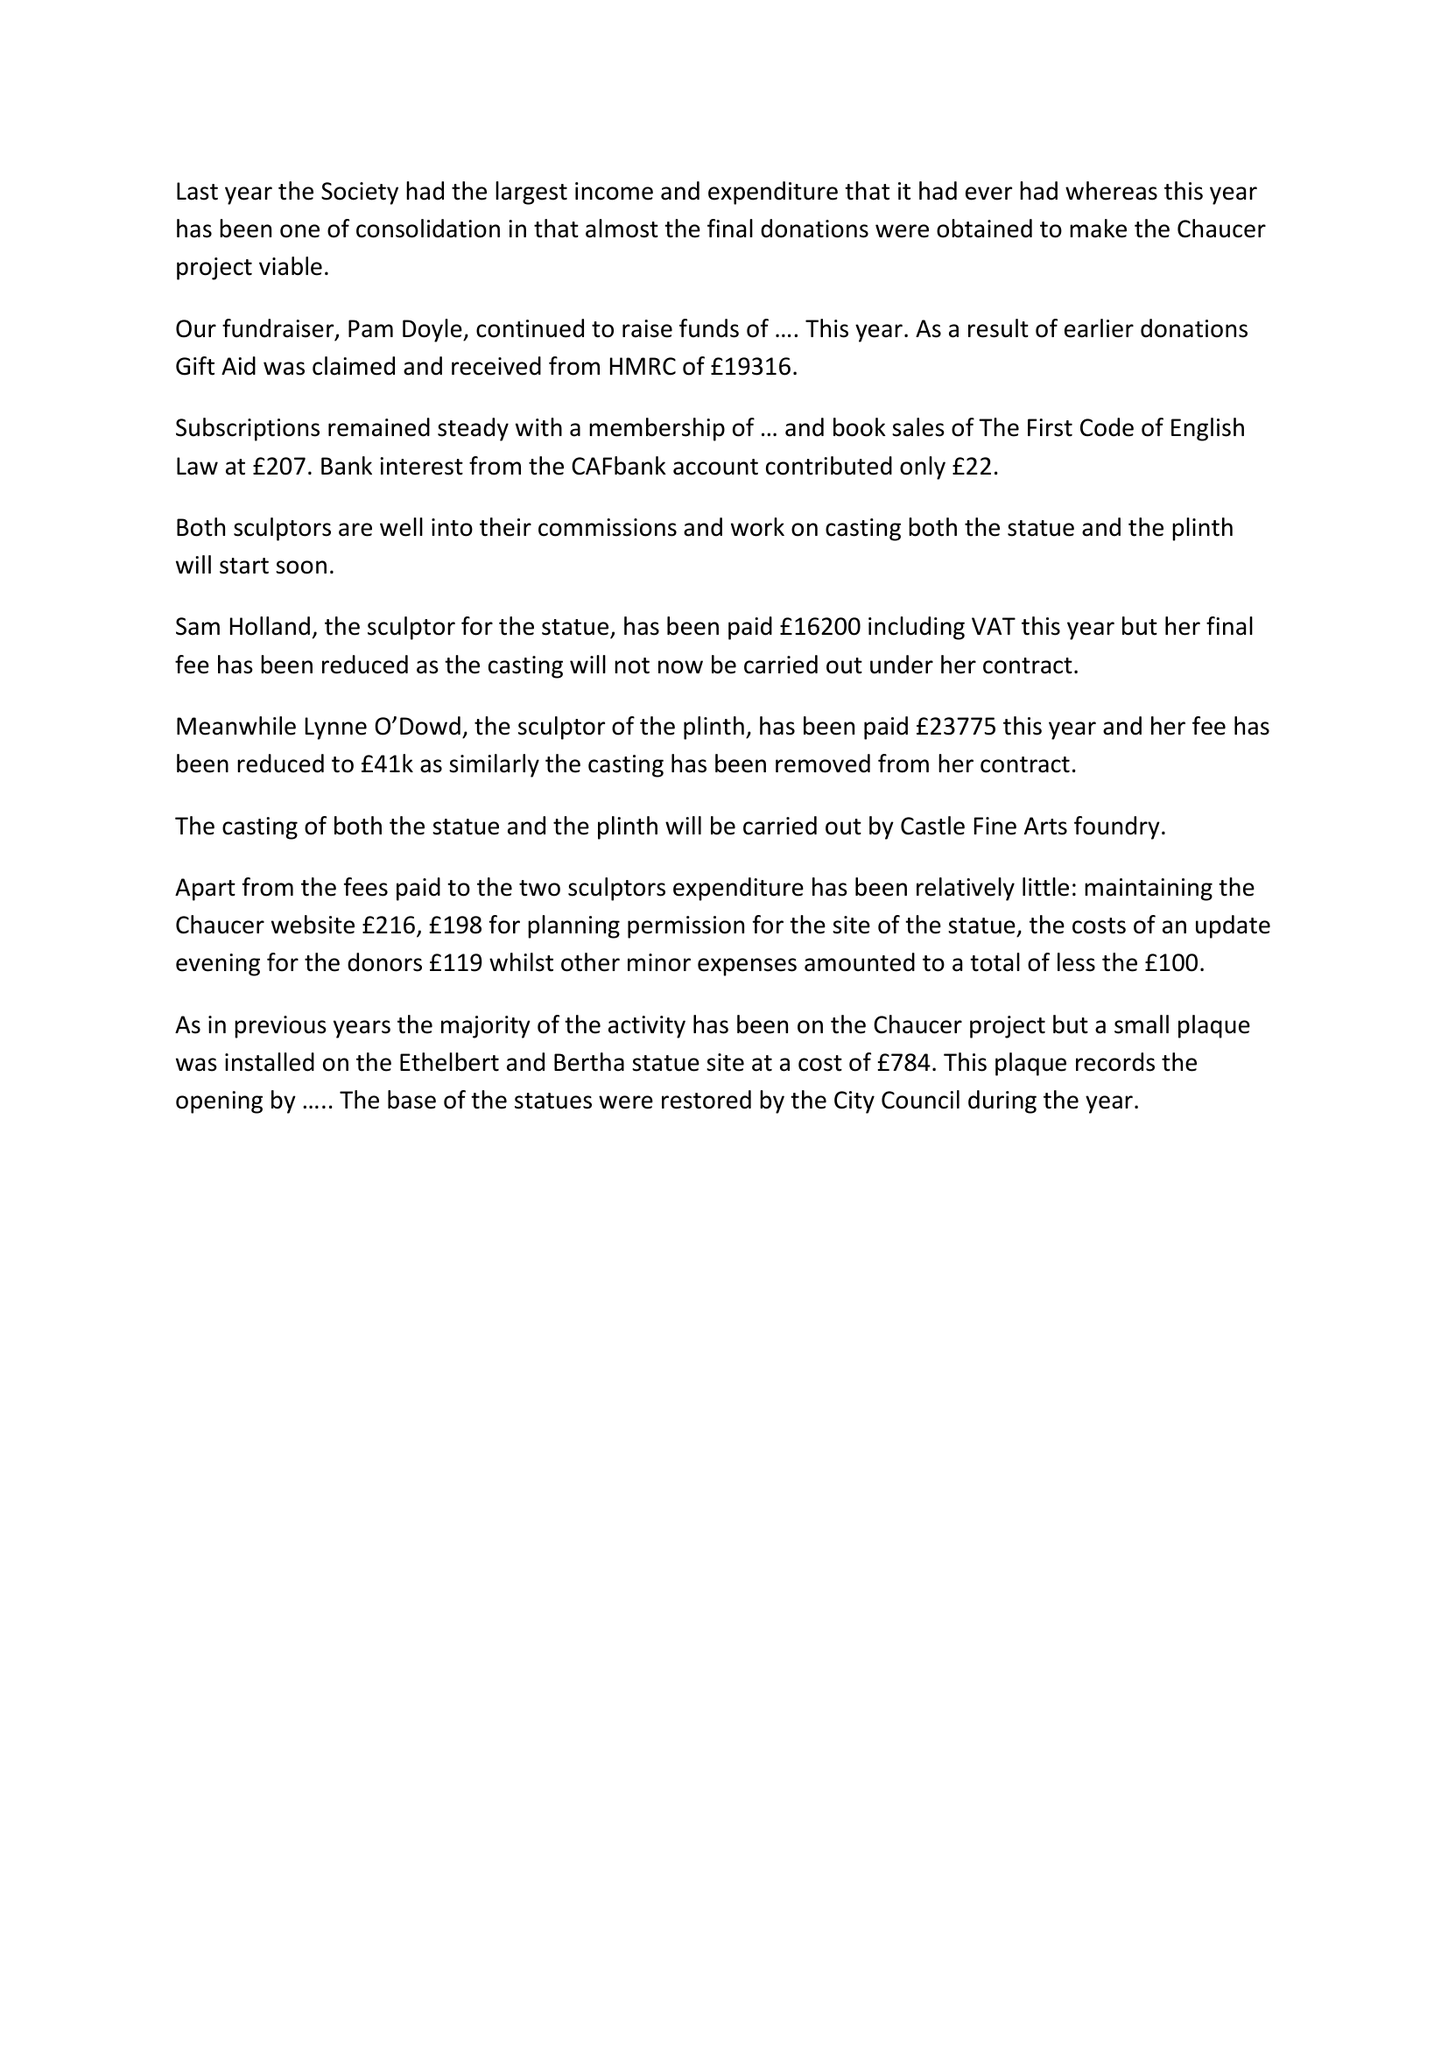What is the value for the address__postcode?
Answer the question using a single word or phrase. None 